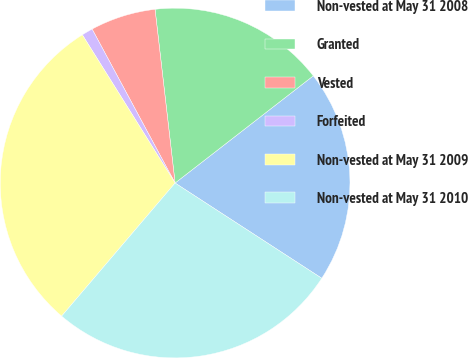Convert chart. <chart><loc_0><loc_0><loc_500><loc_500><pie_chart><fcel>Non-vested at May 31 2008<fcel>Granted<fcel>Vested<fcel>Forfeited<fcel>Non-vested at May 31 2009<fcel>Non-vested at May 31 2010<nl><fcel>19.67%<fcel>16.33%<fcel>6.04%<fcel>1.03%<fcel>29.87%<fcel>27.07%<nl></chart> 